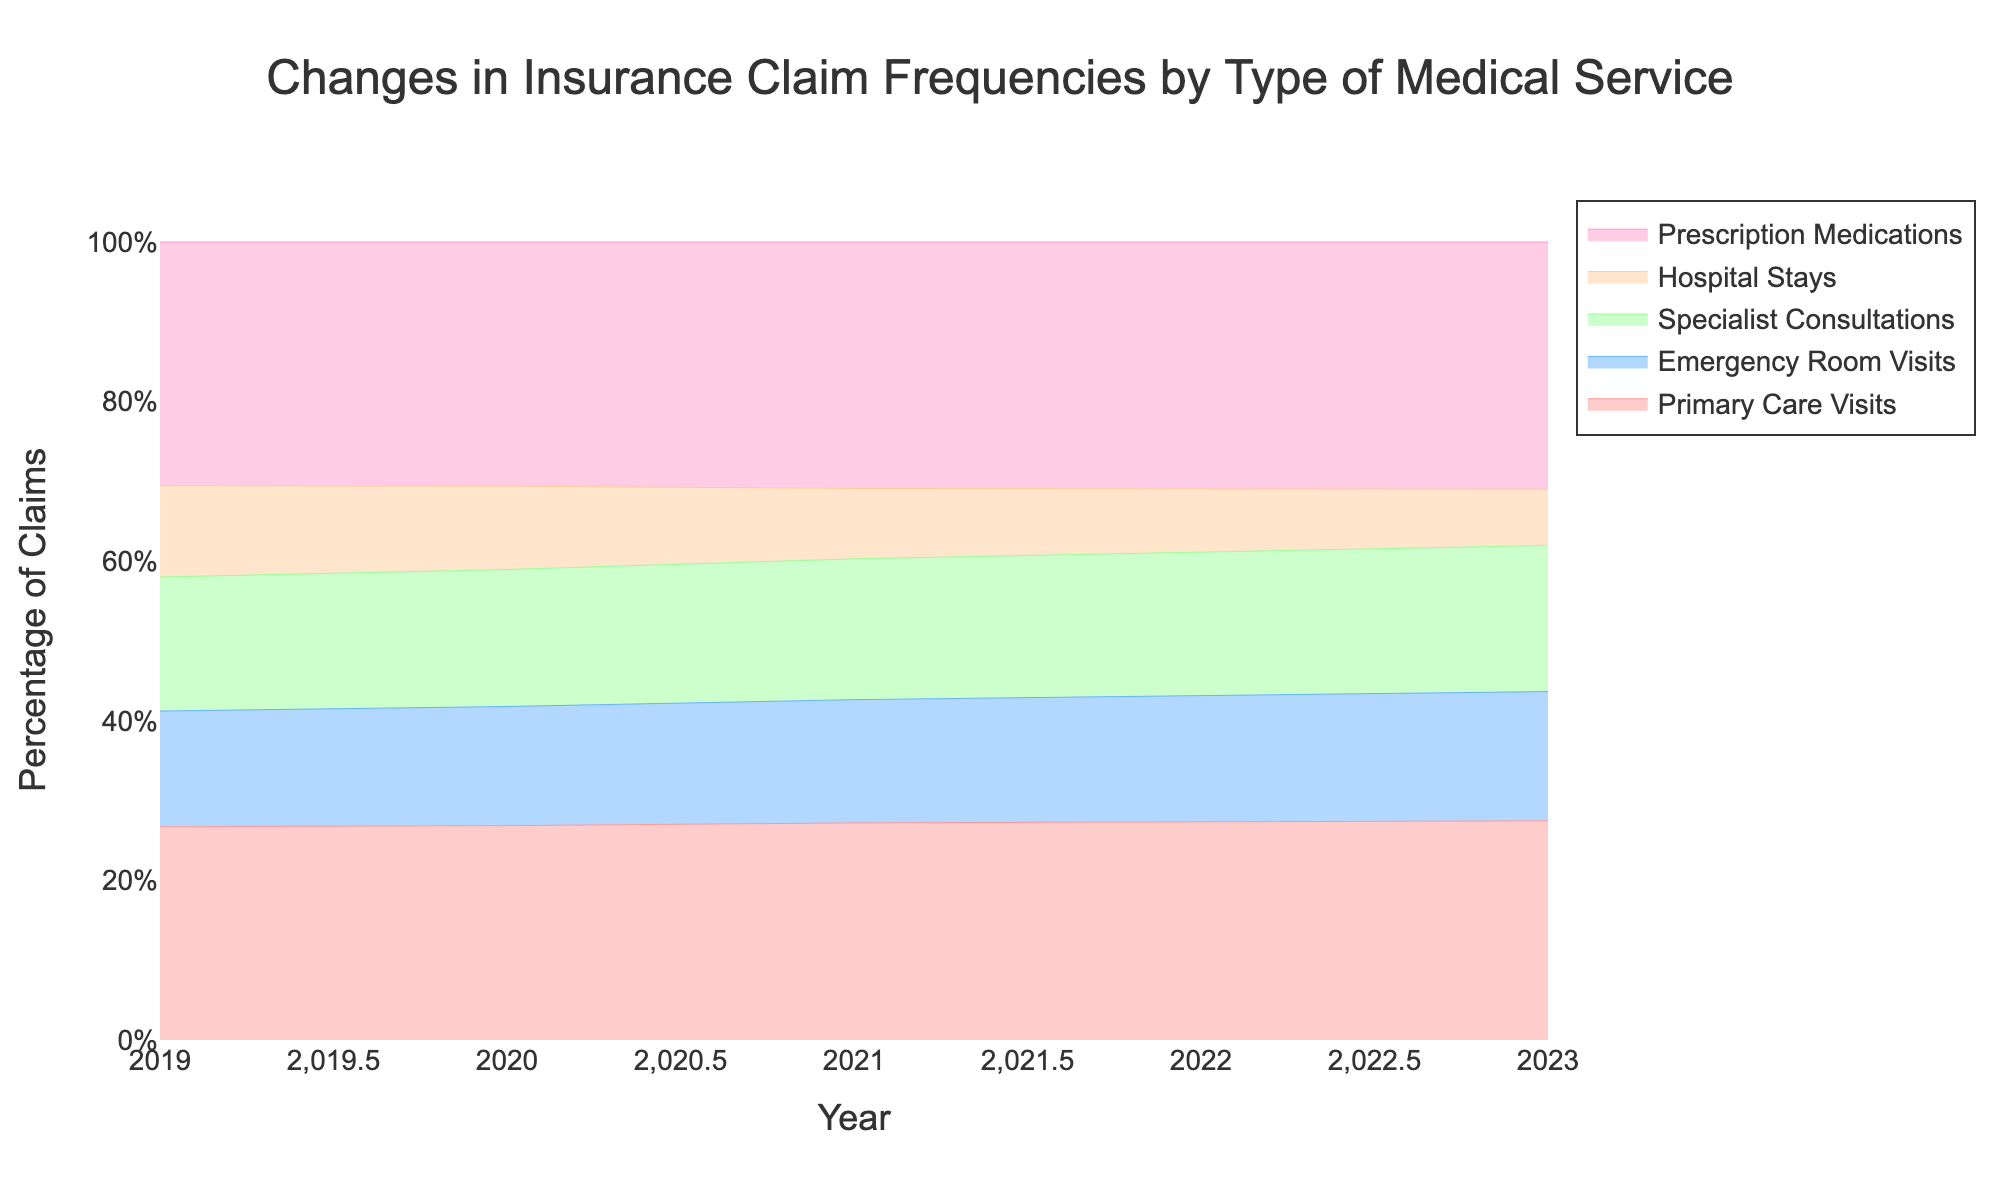What is the title of the figure? The title is usually found at the top of the figure. In this case, it states the main focus of the data visualization.
Answer: Changes in Insurance Claim Frequencies by Type of Medical Service What axis labels are used in the figure? The axis labels indicate what each axis represents. The x-axis shows the "Year," and the y-axis shows the "Percentage of Claims."
Answer: Year; Percentage of Claims Which type of medical service had the highest percentage increase in claims over the five years? To determine this, observe the area represented by each service in the stream graph from 2019 to 2023. The service area that increased the most over time indicates the highest percentage increase. The area for Prescription Medications increased substantially.
Answer: Prescription Medications How did Emergency Room Visits' frequency change between 2021 and 2023? Look at the stream graph section for Emergency Room Visits from 2021 to 2023 and observe the height of the colored area for Emergency Room Visits in these two years. It increased from 2100 in 2021 to 2300 in 2023.
Answer: Increased Between Primary Care Visits and Hospital Stays, which had a more significant decrease in claim frequency from 2019 to 2023? Compare the areas of Primary Care Visits and Hospital Stays from 2019 to 2023. The area for Hospital Stays shrank more significantly than for Primary Care Visits.
Answer: Hospital Stays What percentage of total claims did Prescription Medications represent in 2023? Observe the height of the stream graph in 2023 for Prescription Medications. Since it is a percentage stacked area graph, and Prescription Medications represent the topmost area, the height is roughly equivalent to the percentage.
Answer: 44% Which medical service has consistently increased in frequency every year? Follow each color representing a medical service from 2019 to 2023. Prescription Medications show a steady increase every year without decline.
Answer: Prescription Medications What are the colors representing the different types of medical services in the graph? Each service type is represented by a distinct color in the stream graph. These colors are visual differentiators.
Answer: Primary Care Visits: Light Red, Emergency Room Visits: Light Blue, Specialist Consultations: Light Green, Hospital Stays: Light Orange, Prescription Medications: Light Pink 